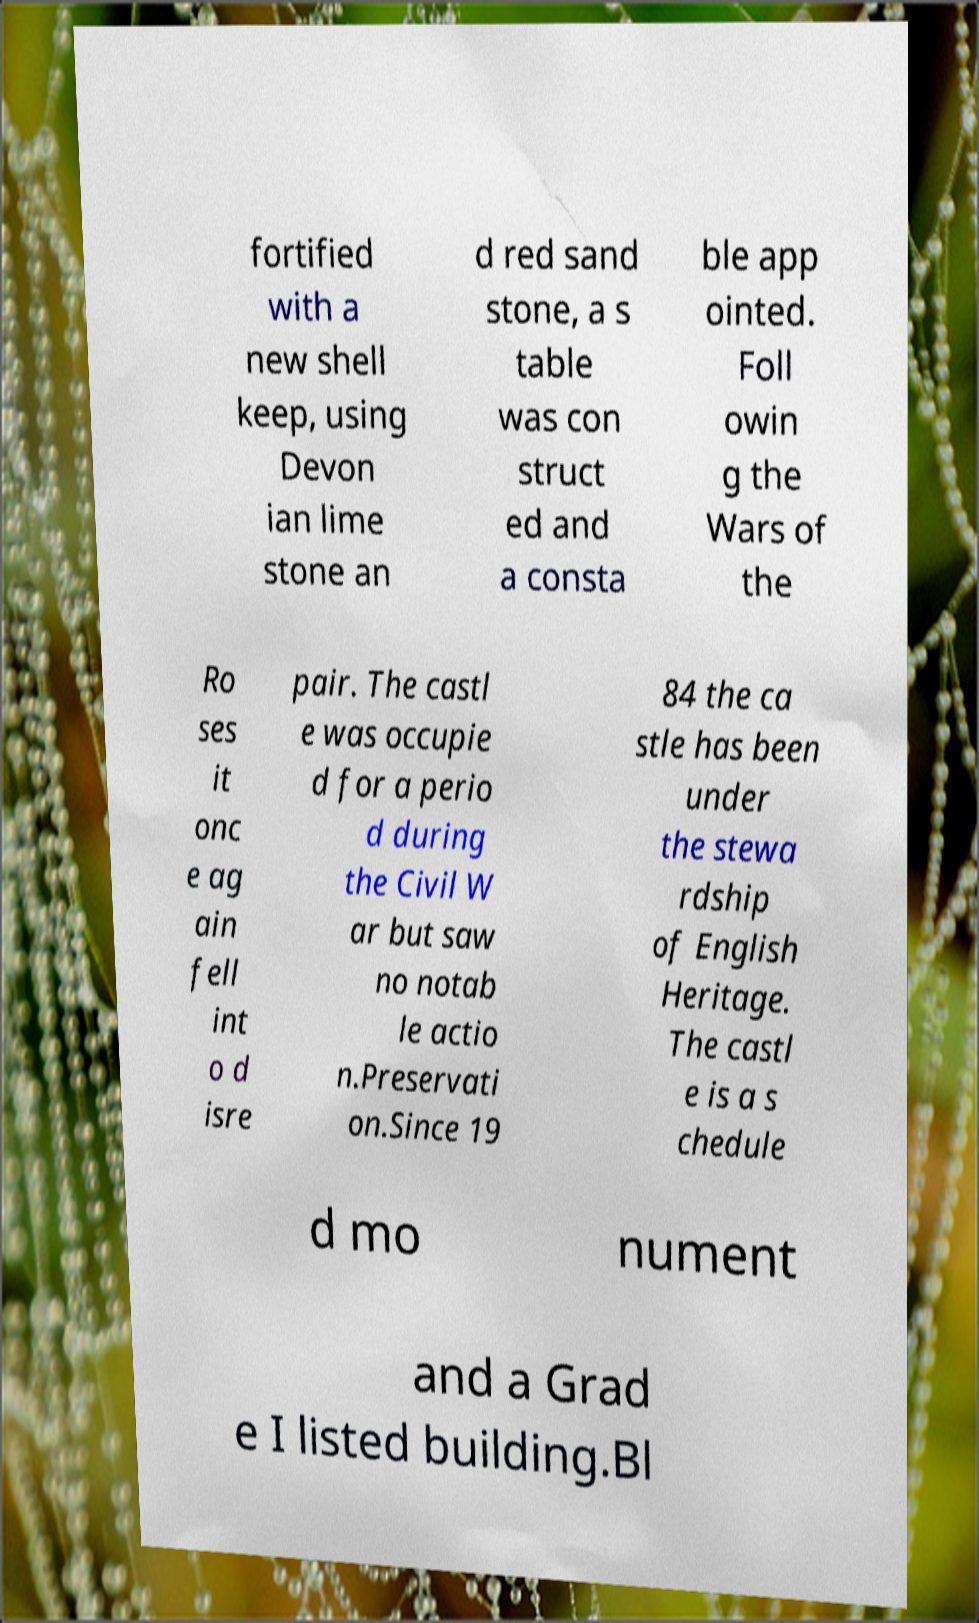For documentation purposes, I need the text within this image transcribed. Could you provide that? fortified with a new shell keep, using Devon ian lime stone an d red sand stone, a s table was con struct ed and a consta ble app ointed. Foll owin g the Wars of the Ro ses it onc e ag ain fell int o d isre pair. The castl e was occupie d for a perio d during the Civil W ar but saw no notab le actio n.Preservati on.Since 19 84 the ca stle has been under the stewa rdship of English Heritage. The castl e is a s chedule d mo nument and a Grad e I listed building.Bl 